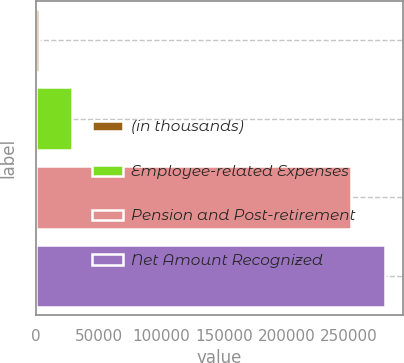Convert chart to OTSL. <chart><loc_0><loc_0><loc_500><loc_500><bar_chart><fcel>(in thousands)<fcel>Employee-related Expenses<fcel>Pension and Post-retirement<fcel>Net Amount Recognized<nl><fcel>2018<fcel>29043.4<fcel>251732<fcel>278757<nl></chart> 